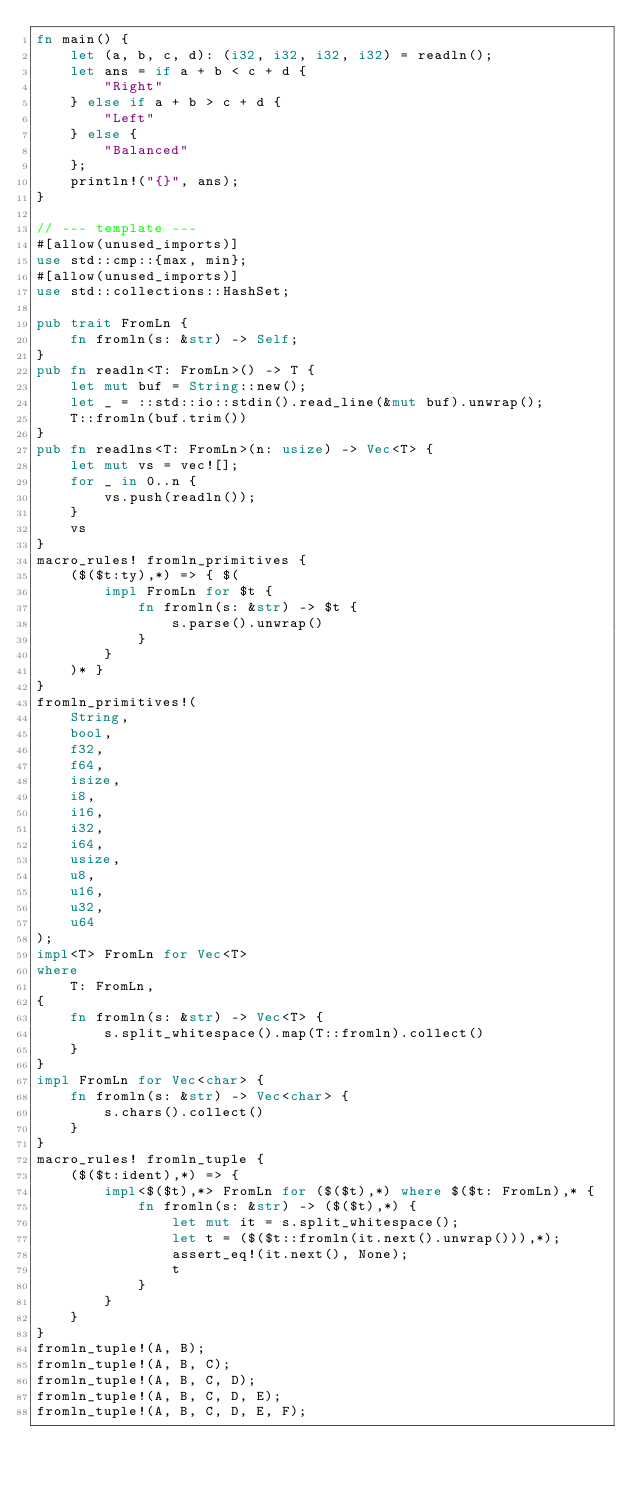Convert code to text. <code><loc_0><loc_0><loc_500><loc_500><_Rust_>fn main() {
    let (a, b, c, d): (i32, i32, i32, i32) = readln();
    let ans = if a + b < c + d {
        "Right"
    } else if a + b > c + d {
        "Left"
    } else {
        "Balanced"
    };
    println!("{}", ans);
}

// --- template ---
#[allow(unused_imports)]
use std::cmp::{max, min};
#[allow(unused_imports)]
use std::collections::HashSet;

pub trait FromLn {
    fn fromln(s: &str) -> Self;
}
pub fn readln<T: FromLn>() -> T {
    let mut buf = String::new();
    let _ = ::std::io::stdin().read_line(&mut buf).unwrap();
    T::fromln(buf.trim())
}
pub fn readlns<T: FromLn>(n: usize) -> Vec<T> {
    let mut vs = vec![];
    for _ in 0..n {
        vs.push(readln());
    }
    vs
}
macro_rules! fromln_primitives {
    ($($t:ty),*) => { $(
        impl FromLn for $t {
            fn fromln(s: &str) -> $t {
                s.parse().unwrap()
            }
        }
    )* }
}
fromln_primitives!(
    String,
    bool,
    f32,
    f64,
    isize,
    i8,
    i16,
    i32,
    i64,
    usize,
    u8,
    u16,
    u32,
    u64
);
impl<T> FromLn for Vec<T>
where
    T: FromLn,
{
    fn fromln(s: &str) -> Vec<T> {
        s.split_whitespace().map(T::fromln).collect()
    }
}
impl FromLn for Vec<char> {
    fn fromln(s: &str) -> Vec<char> {
        s.chars().collect()
    }
}
macro_rules! fromln_tuple {
    ($($t:ident),*) => {
        impl<$($t),*> FromLn for ($($t),*) where $($t: FromLn),* {
            fn fromln(s: &str) -> ($($t),*) {
                let mut it = s.split_whitespace();
                let t = ($($t::fromln(it.next().unwrap())),*);
                assert_eq!(it.next(), None);
                t
            }
        }
    }
}
fromln_tuple!(A, B);
fromln_tuple!(A, B, C);
fromln_tuple!(A, B, C, D);
fromln_tuple!(A, B, C, D, E);
fromln_tuple!(A, B, C, D, E, F);
</code> 